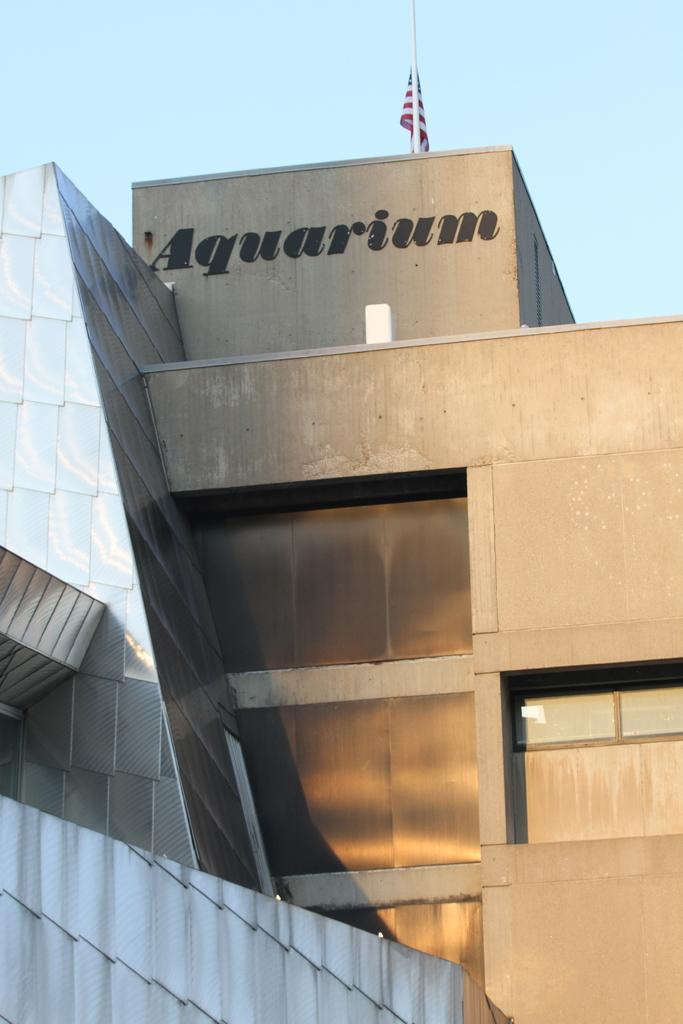<image>
Give a short and clear explanation of the subsequent image. Concert building with American Flag at the top along with the word Aquarium. 